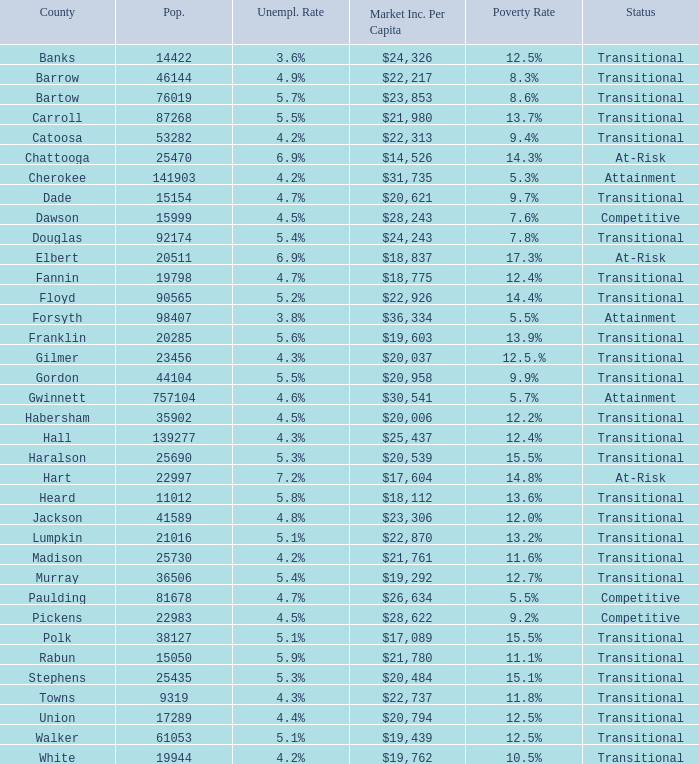What is the market income for each person in the county with a poverty rate of $22,313. 